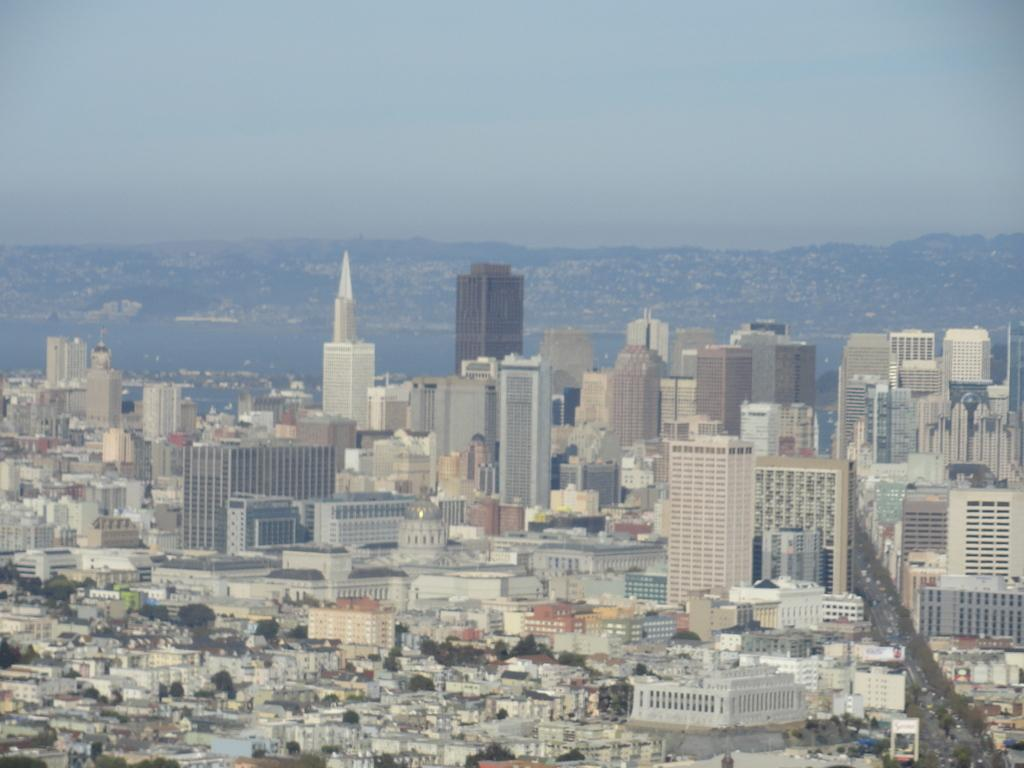What type of structures can be seen in the image? There are buildings in the image. What is present in the foreground of the image? There is a road in the image, and vehicles are on the road. What can be seen in the background of the image? There are mountains, sky, and water visible in the background of the image. What type of notebook is being used to stitch the mountains in the image? There is no notebook or stitching present in the image; it features buildings, a road, vehicles, mountains, sky, and water. 